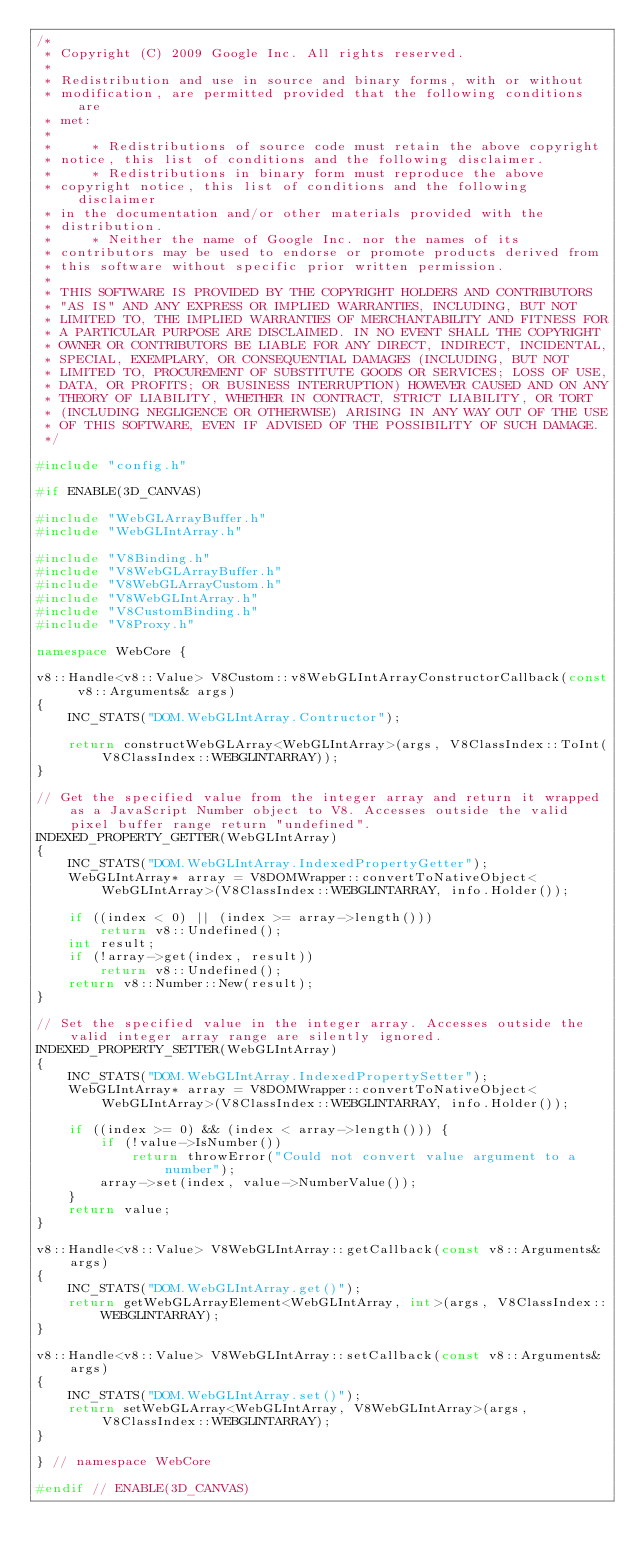Convert code to text. <code><loc_0><loc_0><loc_500><loc_500><_C++_>/*
 * Copyright (C) 2009 Google Inc. All rights reserved.
 *
 * Redistribution and use in source and binary forms, with or without
 * modification, are permitted provided that the following conditions are
 * met:
 *
 *     * Redistributions of source code must retain the above copyright
 * notice, this list of conditions and the following disclaimer.
 *     * Redistributions in binary form must reproduce the above
 * copyright notice, this list of conditions and the following disclaimer
 * in the documentation and/or other materials provided with the
 * distribution.
 *     * Neither the name of Google Inc. nor the names of its
 * contributors may be used to endorse or promote products derived from
 * this software without specific prior written permission.
 *
 * THIS SOFTWARE IS PROVIDED BY THE COPYRIGHT HOLDERS AND CONTRIBUTORS
 * "AS IS" AND ANY EXPRESS OR IMPLIED WARRANTIES, INCLUDING, BUT NOT
 * LIMITED TO, THE IMPLIED WARRANTIES OF MERCHANTABILITY AND FITNESS FOR
 * A PARTICULAR PURPOSE ARE DISCLAIMED. IN NO EVENT SHALL THE COPYRIGHT
 * OWNER OR CONTRIBUTORS BE LIABLE FOR ANY DIRECT, INDIRECT, INCIDENTAL,
 * SPECIAL, EXEMPLARY, OR CONSEQUENTIAL DAMAGES (INCLUDING, BUT NOT
 * LIMITED TO, PROCUREMENT OF SUBSTITUTE GOODS OR SERVICES; LOSS OF USE,
 * DATA, OR PROFITS; OR BUSINESS INTERRUPTION) HOWEVER CAUSED AND ON ANY
 * THEORY OF LIABILITY, WHETHER IN CONTRACT, STRICT LIABILITY, OR TORT
 * (INCLUDING NEGLIGENCE OR OTHERWISE) ARISING IN ANY WAY OUT OF THE USE
 * OF THIS SOFTWARE, EVEN IF ADVISED OF THE POSSIBILITY OF SUCH DAMAGE.
 */

#include "config.h"

#if ENABLE(3D_CANVAS)

#include "WebGLArrayBuffer.h"
#include "WebGLIntArray.h"

#include "V8Binding.h"
#include "V8WebGLArrayBuffer.h"
#include "V8WebGLArrayCustom.h"
#include "V8WebGLIntArray.h"
#include "V8CustomBinding.h"
#include "V8Proxy.h"

namespace WebCore {

v8::Handle<v8::Value> V8Custom::v8WebGLIntArrayConstructorCallback(const v8::Arguments& args)
{
    INC_STATS("DOM.WebGLIntArray.Contructor");

    return constructWebGLArray<WebGLIntArray>(args, V8ClassIndex::ToInt(V8ClassIndex::WEBGLINTARRAY));
}

// Get the specified value from the integer array and return it wrapped as a JavaScript Number object to V8. Accesses outside the valid pixel buffer range return "undefined".
INDEXED_PROPERTY_GETTER(WebGLIntArray)
{
    INC_STATS("DOM.WebGLIntArray.IndexedPropertyGetter");
    WebGLIntArray* array = V8DOMWrapper::convertToNativeObject<WebGLIntArray>(V8ClassIndex::WEBGLINTARRAY, info.Holder());

    if ((index < 0) || (index >= array->length()))
        return v8::Undefined();
    int result;
    if (!array->get(index, result))
        return v8::Undefined();
    return v8::Number::New(result);
}

// Set the specified value in the integer array. Accesses outside the valid integer array range are silently ignored.
INDEXED_PROPERTY_SETTER(WebGLIntArray)
{
    INC_STATS("DOM.WebGLIntArray.IndexedPropertySetter");
    WebGLIntArray* array = V8DOMWrapper::convertToNativeObject<WebGLIntArray>(V8ClassIndex::WEBGLINTARRAY, info.Holder());

    if ((index >= 0) && (index < array->length())) {
        if (!value->IsNumber())
            return throwError("Could not convert value argument to a number");
        array->set(index, value->NumberValue());
    }
    return value;
}

v8::Handle<v8::Value> V8WebGLIntArray::getCallback(const v8::Arguments& args)
{
    INC_STATS("DOM.WebGLIntArray.get()");
    return getWebGLArrayElement<WebGLIntArray, int>(args, V8ClassIndex::WEBGLINTARRAY);
}

v8::Handle<v8::Value> V8WebGLIntArray::setCallback(const v8::Arguments& args)
{
    INC_STATS("DOM.WebGLIntArray.set()");
    return setWebGLArray<WebGLIntArray, V8WebGLIntArray>(args, V8ClassIndex::WEBGLINTARRAY);
}

} // namespace WebCore

#endif // ENABLE(3D_CANVAS)
</code> 